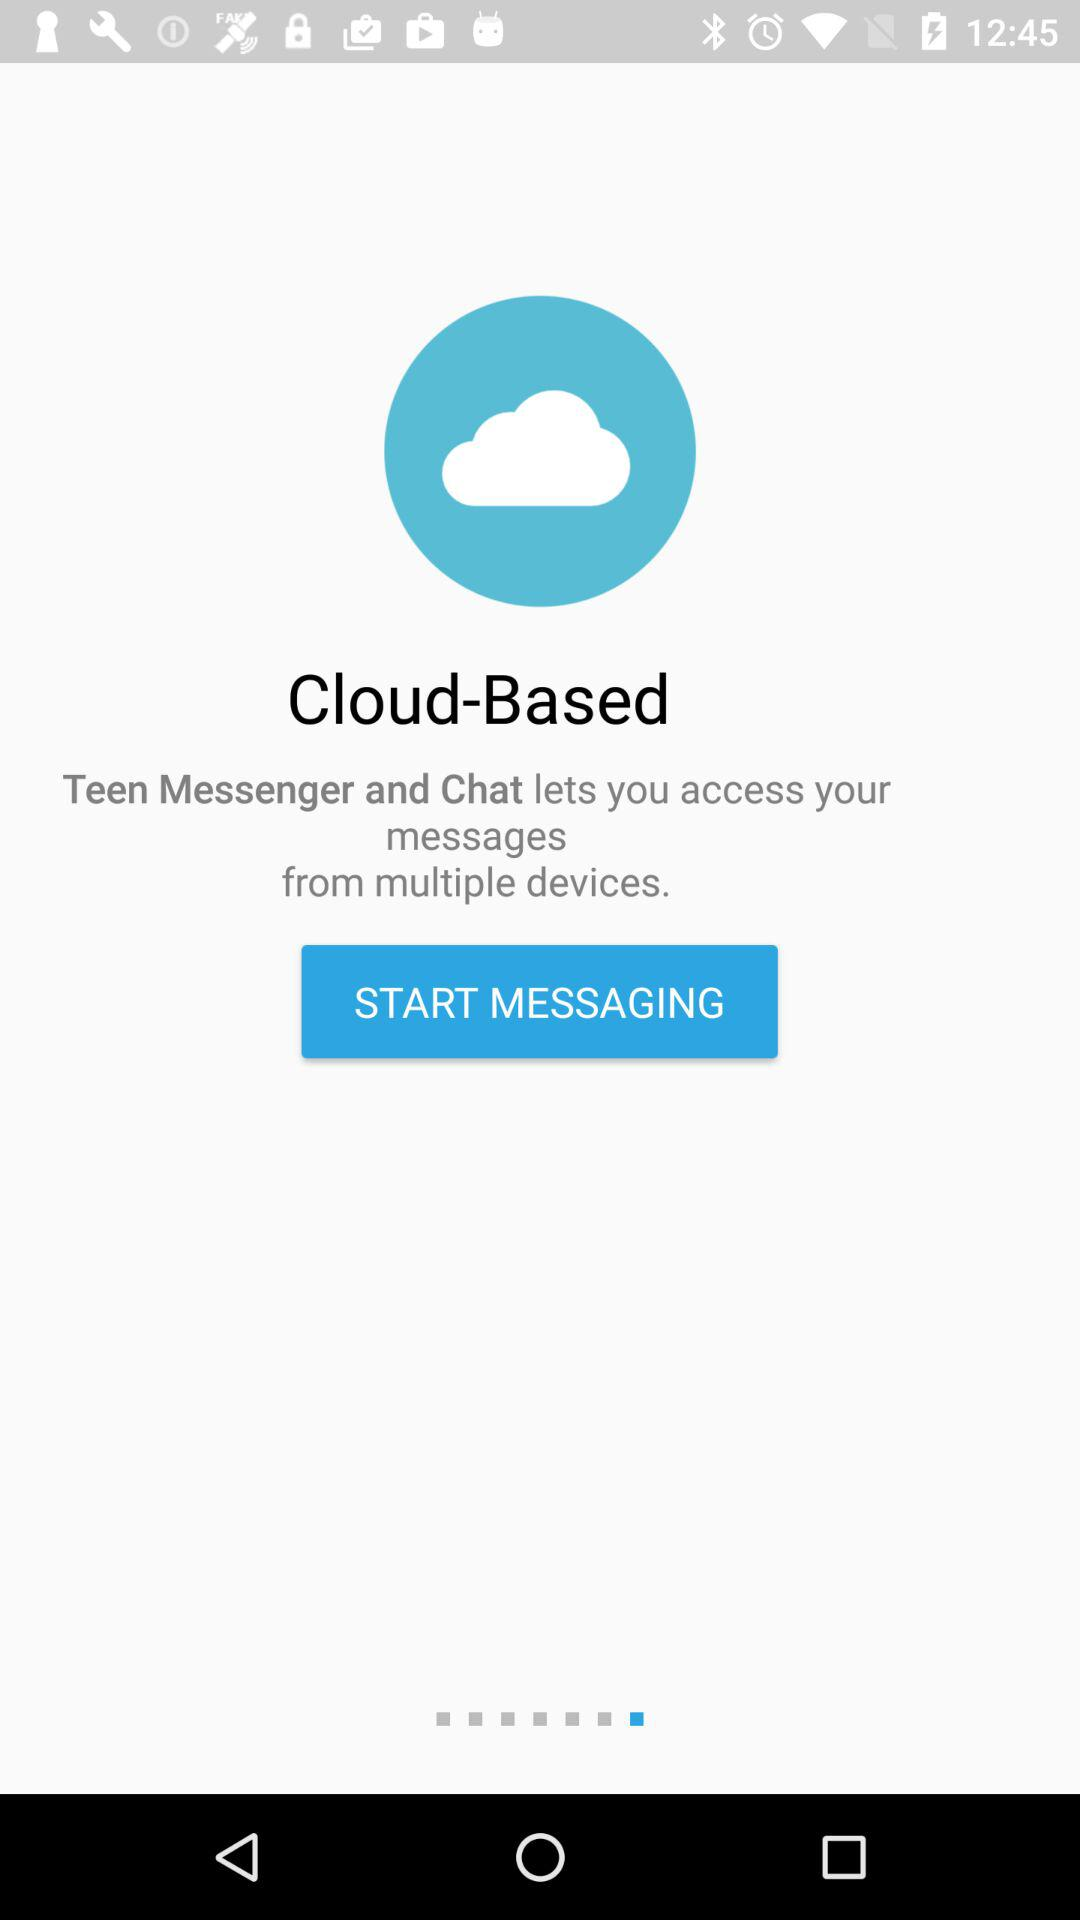What is the name of the application? The name of the application is "Teen Messenger and Chat". 